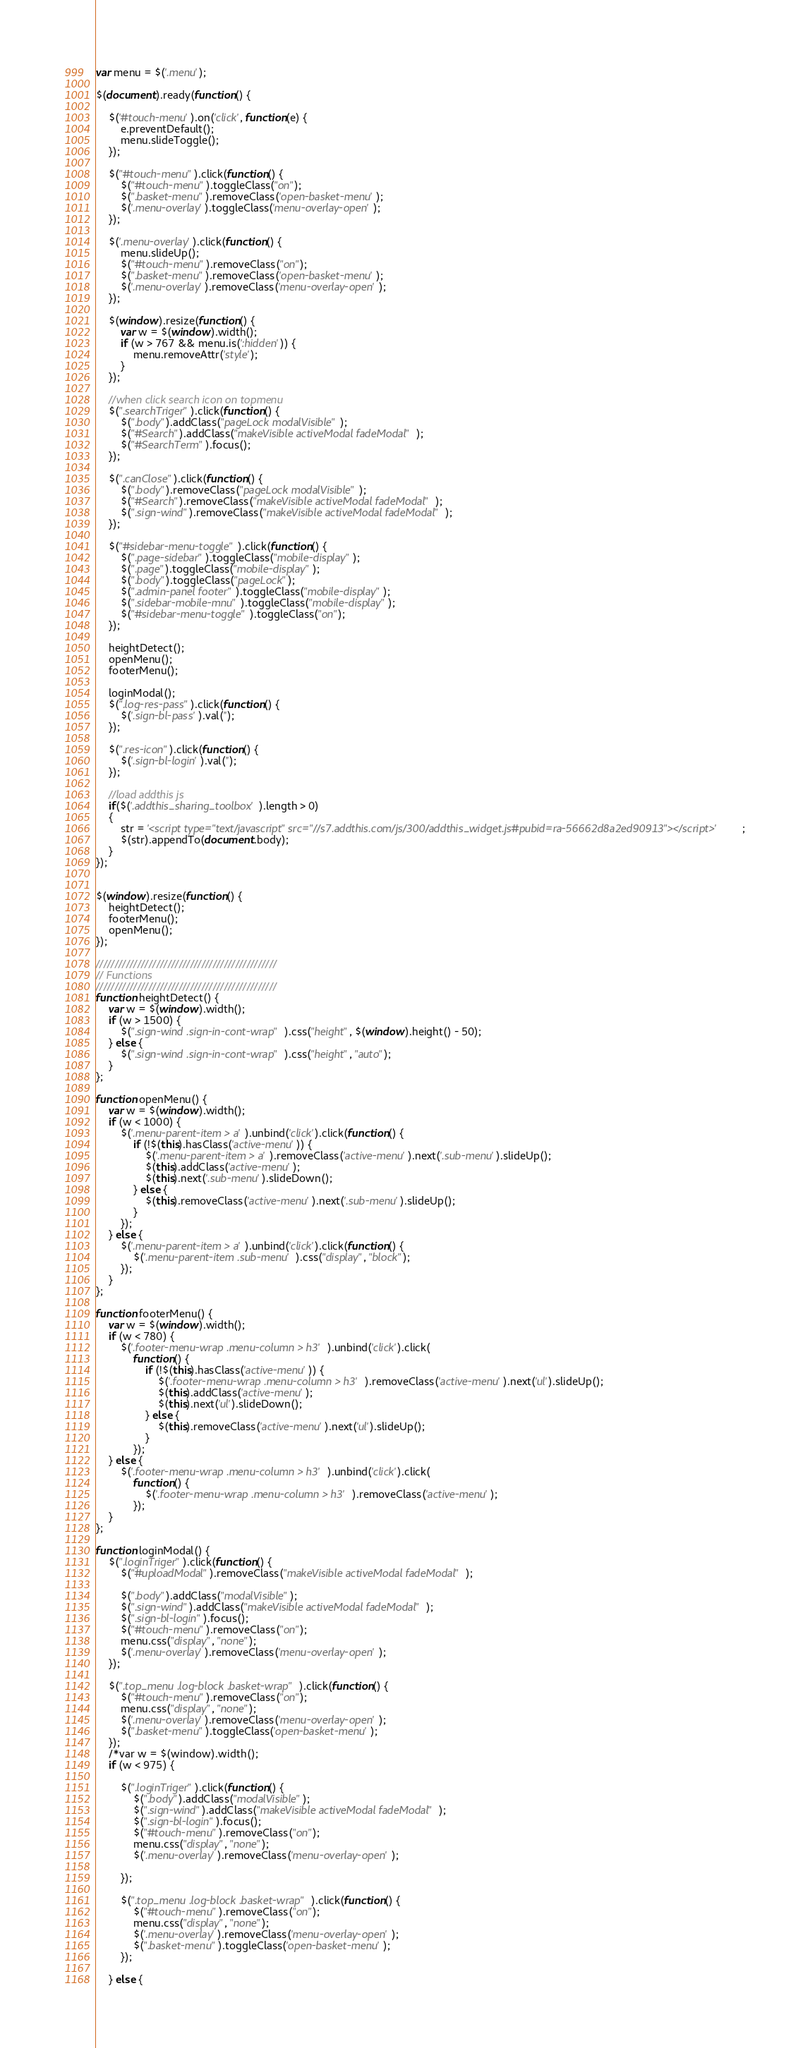<code> <loc_0><loc_0><loc_500><loc_500><_JavaScript_>var menu = $('.menu');

$(document).ready(function() {
    
    $('#touch-menu').on('click', function(e) {
        e.preventDefault();
        menu.slideToggle();
    });

    $("#touch-menu").click(function() {
        $("#touch-menu").toggleClass("on");
        $(".basket-menu").removeClass('open-basket-menu');
        $('.menu-overlay').toggleClass('menu-overlay-open');
    });

    $('.menu-overlay').click(function() {
        menu.slideUp();
        $("#touch-menu").removeClass("on");
        $(".basket-menu").removeClass('open-basket-menu');
        $('.menu-overlay').removeClass('menu-overlay-open');
    });         

    $(window).resize(function() {
        var w = $(window).width();
        if (w > 767 && menu.is(':hidden')) {
            menu.removeAttr('style');
        }
    });
    
    //when click search icon on topmenu
    $(".searchTriger").click(function() {
        $(".body").addClass("pageLock modalVisible");
        $("#Search").addClass("makeVisible activeModal fadeModal");
        $("#SearchTerm").focus();
    });
    
    $(".canClose").click(function() {
        $(".body").removeClass("pageLock modalVisible");
        $("#Search").removeClass("makeVisible activeModal fadeModal");
        $(".sign-wind").removeClass("makeVisible activeModal fadeModal");
    });
    
    $("#sidebar-menu-toggle").click(function() {
        $(".page-sidebar").toggleClass("mobile-display");
        $(".page").toggleClass("mobile-display");
        $(".body").toggleClass("pageLock");
        $(".admin-panel footer").toggleClass("mobile-display");
        $(".sidebar-mobile-mnu").toggleClass("mobile-display");
        $("#sidebar-menu-toggle").toggleClass("on");
    });
    
    heightDetect();
    openMenu();
    footerMenu();
    
    loginModal(); 
    $(".log-res-pass").click(function() {
        $('.sign-bl-pass').val('');
    });

    $(".res-icon").click(function() {
        $('.sign-bl-login').val('');
    }); 
    
    //load addthis js
    if($('.addthis_sharing_toolbox').length > 0) 
    {
        str = '<script type="text/javascript" src="//s7.addthis.com/js/300/addthis_widget.js#pubid=ra-56662d8a2ed90913"></script>';
        $(str).appendTo(document.body);
    }
});


$(window).resize(function() {
    heightDetect();
    footerMenu();
    openMenu();
});

////////////////////////////////////////////////
// Functions
////////////////////////////////////////////////
function heightDetect() {
    var w = $(window).width();
    if (w > 1500) {
        $(".sign-wind .sign-in-cont-wrap").css("height", $(window).height() - 50);
    } else {
        $(".sign-wind .sign-in-cont-wrap").css("height", "auto");
    }
};     

function openMenu() {
    var w = $(window).width();
    if (w < 1000) {
        $('.menu-parent-item > a').unbind('click').click(function() {
            if (!$(this).hasClass('active-menu')) {
                $('.menu-parent-item > a').removeClass('active-menu').next('.sub-menu').slideUp();
                $(this).addClass('active-menu');
                $(this).next('.sub-menu').slideDown();
            } else {
                $(this).removeClass('active-menu').next('.sub-menu').slideUp();
            }
        });
    } else {
        $('.menu-parent-item > a').unbind('click').click(function() {
            $('.menu-parent-item .sub-menu').css("display", "block");
        });
    }
};

function footerMenu() {
    var w = $(window).width();
    if (w < 780) {
        $('.footer-menu-wrap .menu-column > h3').unbind('click').click(
            function() {
                if (!$(this).hasClass('active-menu')) {
                    $('.footer-menu-wrap .menu-column > h3').removeClass('active-menu').next('ul').slideUp();
                    $(this).addClass('active-menu');
                    $(this).next('ul').slideDown();
                } else {
                    $(this).removeClass('active-menu').next('ul').slideUp();
                }
            });
    } else {
        $('.footer-menu-wrap .menu-column > h3').unbind('click').click(
            function() {
                $('.footer-menu-wrap .menu-column > h3').removeClass('active-menu');
            });
    }
};

function loginModal() {
    $(".loginTriger").click(function() {
        $("#uploadModal").removeClass("makeVisible activeModal fadeModal");
        
        $(".body").addClass("modalVisible");
        $(".sign-wind").addClass("makeVisible activeModal fadeModal");
        $(".sign-bl-login").focus();
        $("#touch-menu").removeClass("on");
        menu.css("display", "none");
        $('.menu-overlay').removeClass('menu-overlay-open');
    });
    
    $(".top_menu .log-block .basket-wrap").click(function() {
        $("#touch-menu").removeClass("on");
        menu.css("display", "none");
        $('.menu-overlay').removeClass('menu-overlay-open');
        $(".basket-menu").toggleClass('open-basket-menu');
    });
    /*var w = $(window).width();
    if (w < 975) {

        $(".loginTriger").click(function() {
            $(".body").addClass("modalVisible");
            $(".sign-wind").addClass("makeVisible activeModal fadeModal");
            $(".sign-bl-login").focus();
            $("#touch-menu").removeClass("on");
            menu.css("display", "none");
            $('.menu-overlay').removeClass('menu-overlay-open');

        });

        $(".top_menu .log-block .basket-wrap").click(function() {
            $("#touch-menu").removeClass("on");
            menu.css("display", "none");
            $('.menu-overlay').removeClass('menu-overlay-open');
            $(".basket-menu").toggleClass('open-basket-menu');
        });

    } else {
</code> 